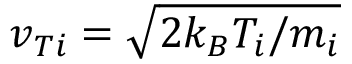Convert formula to latex. <formula><loc_0><loc_0><loc_500><loc_500>v _ { T i } = \sqrt { 2 k _ { B } T _ { i } / m _ { i } }</formula> 